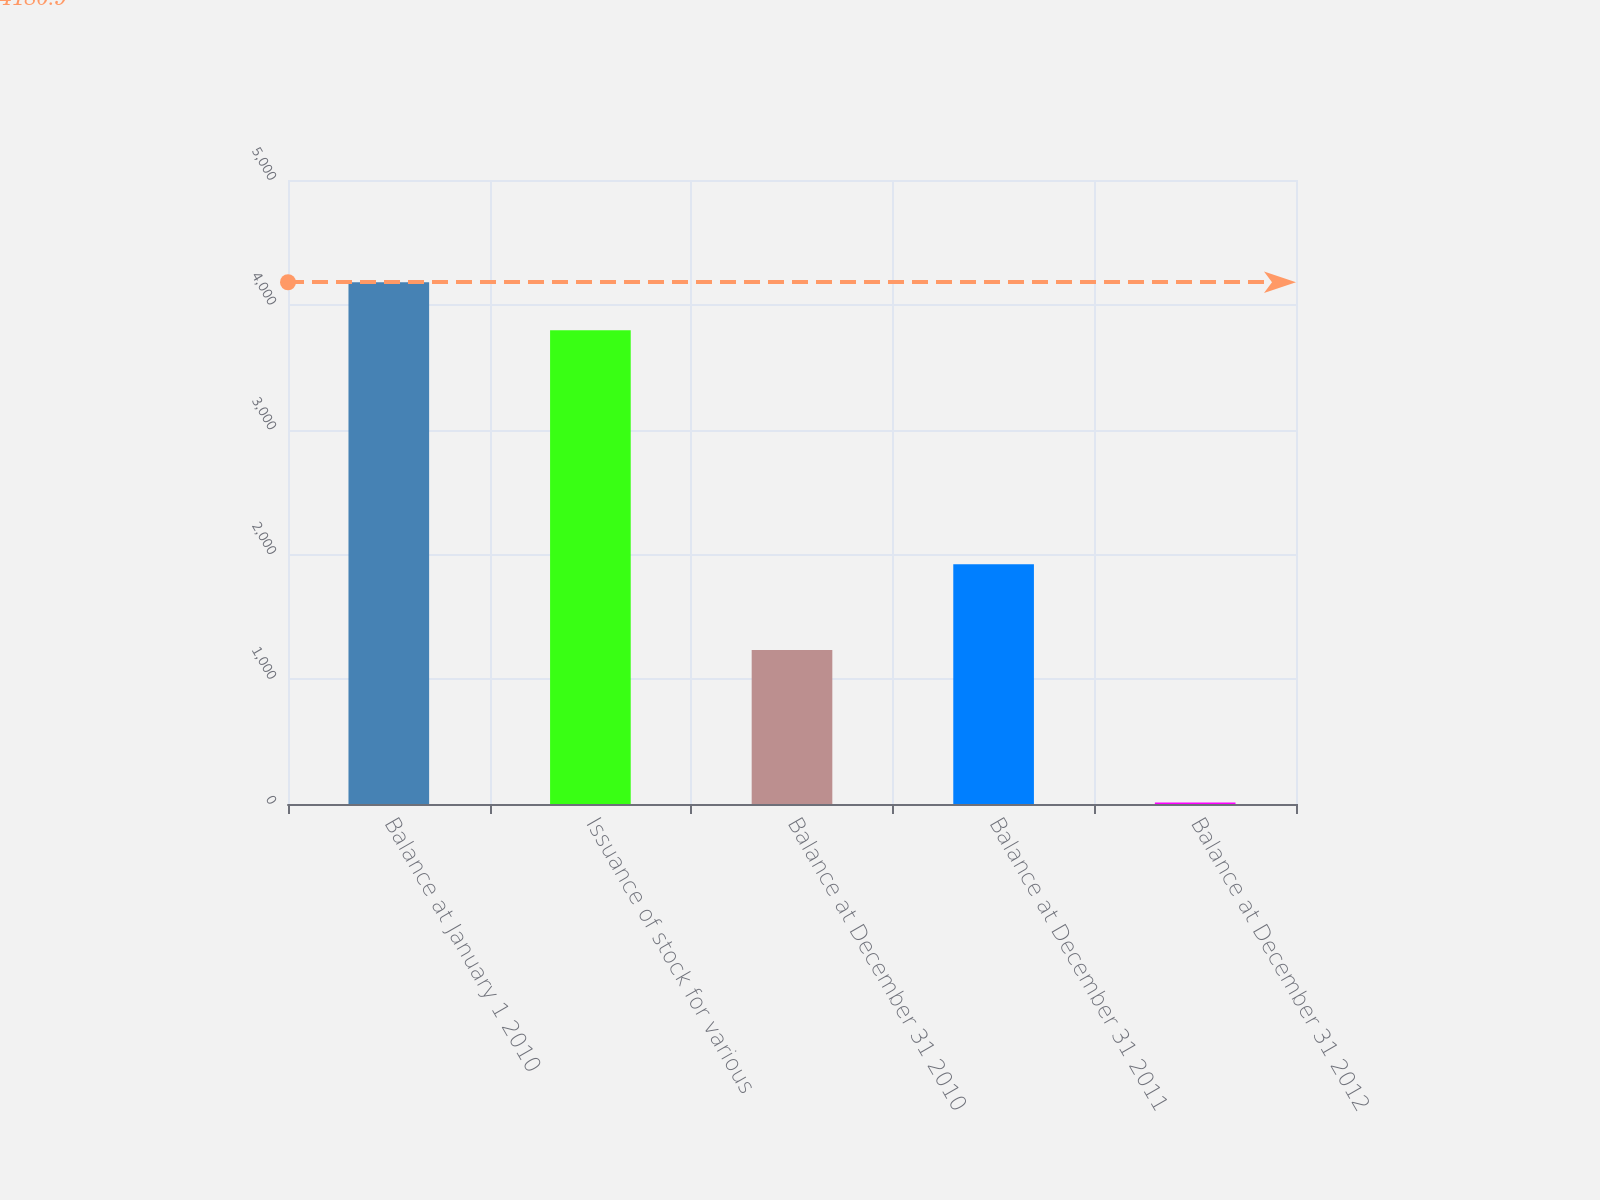Convert chart to OTSL. <chart><loc_0><loc_0><loc_500><loc_500><bar_chart><fcel>Balance at January 1 2010<fcel>Issuance of stock for various<fcel>Balance at December 31 2010<fcel>Balance at December 31 2011<fcel>Balance at December 31 2012<nl><fcel>4180.9<fcel>3796<fcel>1234<fcel>1921<fcel>13<nl></chart> 